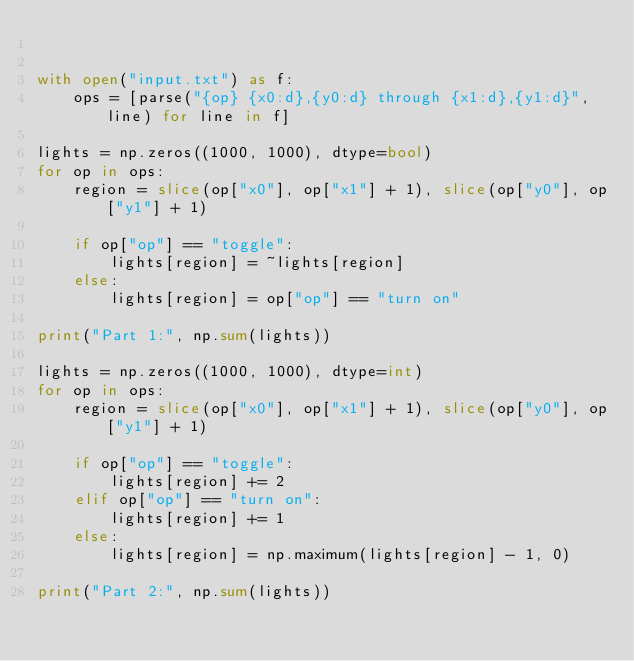Convert code to text. <code><loc_0><loc_0><loc_500><loc_500><_Python_>

with open("input.txt") as f:
    ops = [parse("{op} {x0:d},{y0:d} through {x1:d},{y1:d}", line) for line in f]

lights = np.zeros((1000, 1000), dtype=bool)
for op in ops:
    region = slice(op["x0"], op["x1"] + 1), slice(op["y0"], op["y1"] + 1)

    if op["op"] == "toggle":
        lights[region] = ~lights[region]
    else:
        lights[region] = op["op"] == "turn on"

print("Part 1:", np.sum(lights))

lights = np.zeros((1000, 1000), dtype=int)
for op in ops:
    region = slice(op["x0"], op["x1"] + 1), slice(op["y0"], op["y1"] + 1)

    if op["op"] == "toggle":
        lights[region] += 2
    elif op["op"] == "turn on":
        lights[region] += 1
    else:
        lights[region] = np.maximum(lights[region] - 1, 0)

print("Part 2:", np.sum(lights))
</code> 